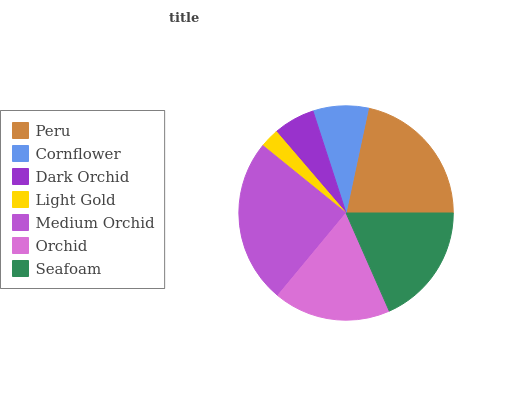Is Light Gold the minimum?
Answer yes or no. Yes. Is Medium Orchid the maximum?
Answer yes or no. Yes. Is Cornflower the minimum?
Answer yes or no. No. Is Cornflower the maximum?
Answer yes or no. No. Is Peru greater than Cornflower?
Answer yes or no. Yes. Is Cornflower less than Peru?
Answer yes or no. Yes. Is Cornflower greater than Peru?
Answer yes or no. No. Is Peru less than Cornflower?
Answer yes or no. No. Is Orchid the high median?
Answer yes or no. Yes. Is Orchid the low median?
Answer yes or no. Yes. Is Medium Orchid the high median?
Answer yes or no. No. Is Seafoam the low median?
Answer yes or no. No. 